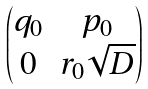Convert formula to latex. <formula><loc_0><loc_0><loc_500><loc_500>\begin{pmatrix} q _ { 0 } & p _ { 0 } \\ 0 & r _ { 0 } \sqrt { D } \end{pmatrix}</formula> 